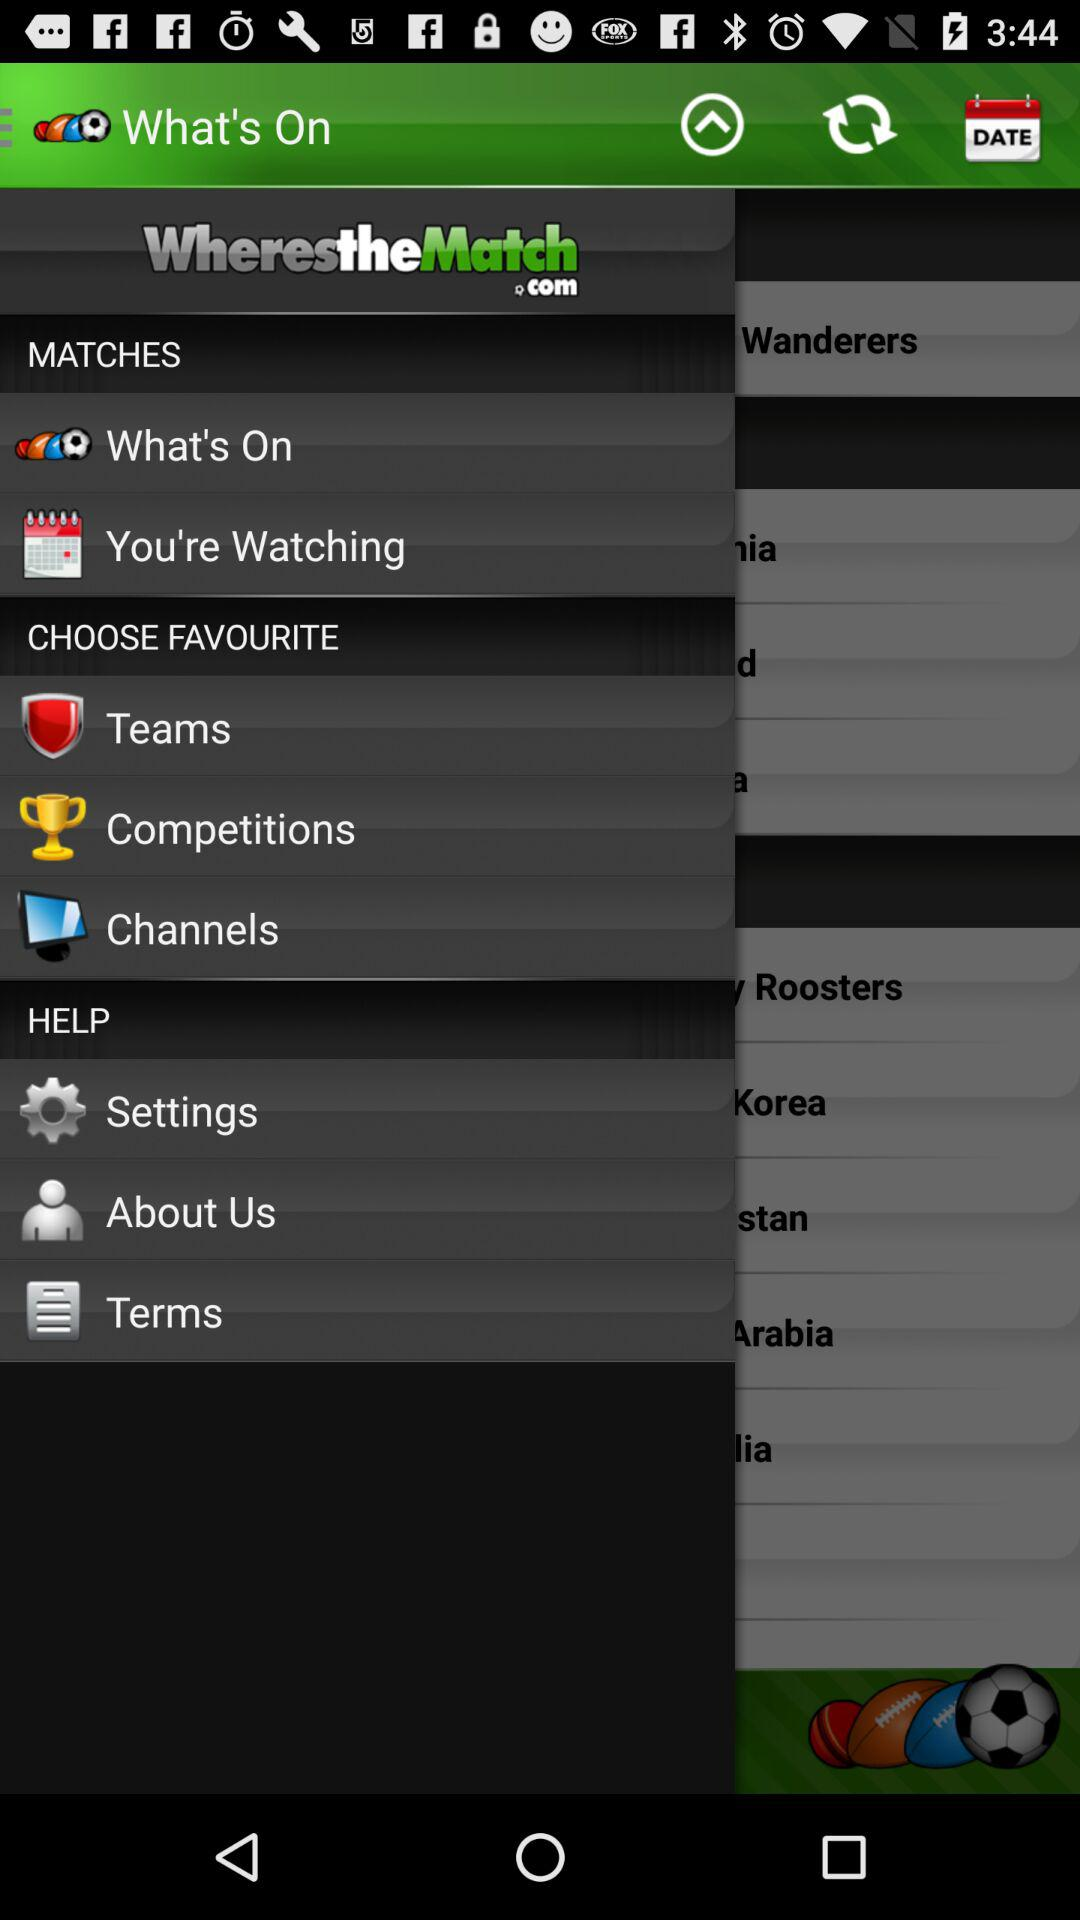What is the name of the application? The name of the application is "WherestheMatch". 